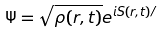Convert formula to latex. <formula><loc_0><loc_0><loc_500><loc_500>\Psi = { \sqrt { \rho ( r , t ) } } e ^ { i S ( r , t ) / } \,</formula> 